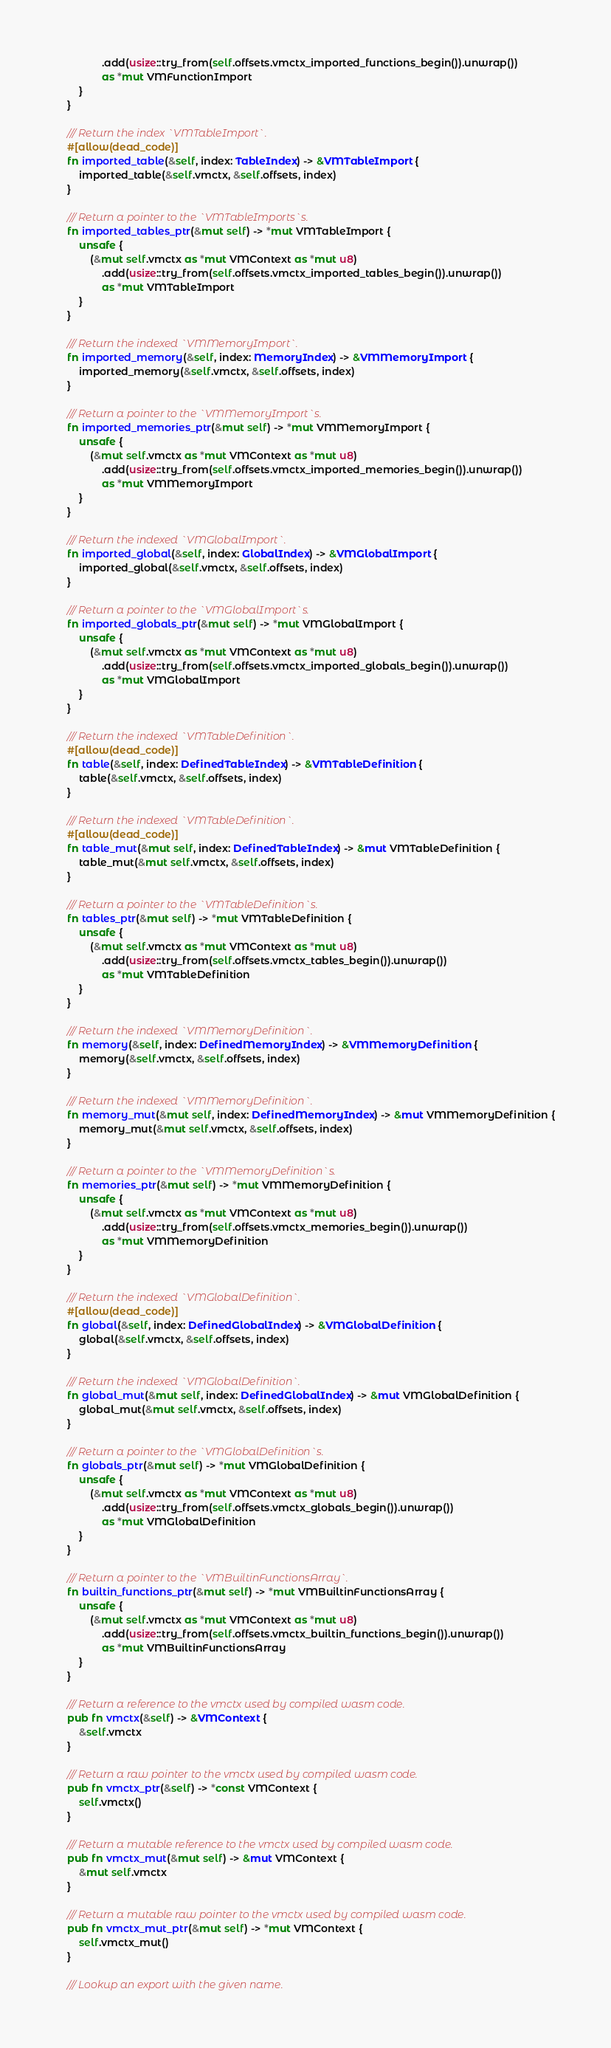<code> <loc_0><loc_0><loc_500><loc_500><_Rust_>                .add(usize::try_from(self.offsets.vmctx_imported_functions_begin()).unwrap())
                as *mut VMFunctionImport
        }
    }

    /// Return the index `VMTableImport`.
    #[allow(dead_code)]
    fn imported_table(&self, index: TableIndex) -> &VMTableImport {
        imported_table(&self.vmctx, &self.offsets, index)
    }

    /// Return a pointer to the `VMTableImports`s.
    fn imported_tables_ptr(&mut self) -> *mut VMTableImport {
        unsafe {
            (&mut self.vmctx as *mut VMContext as *mut u8)
                .add(usize::try_from(self.offsets.vmctx_imported_tables_begin()).unwrap())
                as *mut VMTableImport
        }
    }

    /// Return the indexed `VMMemoryImport`.
    fn imported_memory(&self, index: MemoryIndex) -> &VMMemoryImport {
        imported_memory(&self.vmctx, &self.offsets, index)
    }

    /// Return a pointer to the `VMMemoryImport`s.
    fn imported_memories_ptr(&mut self) -> *mut VMMemoryImport {
        unsafe {
            (&mut self.vmctx as *mut VMContext as *mut u8)
                .add(usize::try_from(self.offsets.vmctx_imported_memories_begin()).unwrap())
                as *mut VMMemoryImport
        }
    }

    /// Return the indexed `VMGlobalImport`.
    fn imported_global(&self, index: GlobalIndex) -> &VMGlobalImport {
        imported_global(&self.vmctx, &self.offsets, index)
    }

    /// Return a pointer to the `VMGlobalImport`s.
    fn imported_globals_ptr(&mut self) -> *mut VMGlobalImport {
        unsafe {
            (&mut self.vmctx as *mut VMContext as *mut u8)
                .add(usize::try_from(self.offsets.vmctx_imported_globals_begin()).unwrap())
                as *mut VMGlobalImport
        }
    }

    /// Return the indexed `VMTableDefinition`.
    #[allow(dead_code)]
    fn table(&self, index: DefinedTableIndex) -> &VMTableDefinition {
        table(&self.vmctx, &self.offsets, index)
    }

    /// Return the indexed `VMTableDefinition`.
    #[allow(dead_code)]
    fn table_mut(&mut self, index: DefinedTableIndex) -> &mut VMTableDefinition {
        table_mut(&mut self.vmctx, &self.offsets, index)
    }

    /// Return a pointer to the `VMTableDefinition`s.
    fn tables_ptr(&mut self) -> *mut VMTableDefinition {
        unsafe {
            (&mut self.vmctx as *mut VMContext as *mut u8)
                .add(usize::try_from(self.offsets.vmctx_tables_begin()).unwrap())
                as *mut VMTableDefinition
        }
    }

    /// Return the indexed `VMMemoryDefinition`.
    fn memory(&self, index: DefinedMemoryIndex) -> &VMMemoryDefinition {
        memory(&self.vmctx, &self.offsets, index)
    }

    /// Return the indexed `VMMemoryDefinition`.
    fn memory_mut(&mut self, index: DefinedMemoryIndex) -> &mut VMMemoryDefinition {
        memory_mut(&mut self.vmctx, &self.offsets, index)
    }

    /// Return a pointer to the `VMMemoryDefinition`s.
    fn memories_ptr(&mut self) -> *mut VMMemoryDefinition {
        unsafe {
            (&mut self.vmctx as *mut VMContext as *mut u8)
                .add(usize::try_from(self.offsets.vmctx_memories_begin()).unwrap())
                as *mut VMMemoryDefinition
        }
    }

    /// Return the indexed `VMGlobalDefinition`.
    #[allow(dead_code)]
    fn global(&self, index: DefinedGlobalIndex) -> &VMGlobalDefinition {
        global(&self.vmctx, &self.offsets, index)
    }

    /// Return the indexed `VMGlobalDefinition`.
    fn global_mut(&mut self, index: DefinedGlobalIndex) -> &mut VMGlobalDefinition {
        global_mut(&mut self.vmctx, &self.offsets, index)
    }

    /// Return a pointer to the `VMGlobalDefinition`s.
    fn globals_ptr(&mut self) -> *mut VMGlobalDefinition {
        unsafe {
            (&mut self.vmctx as *mut VMContext as *mut u8)
                .add(usize::try_from(self.offsets.vmctx_globals_begin()).unwrap())
                as *mut VMGlobalDefinition
        }
    }

    /// Return a pointer to the `VMBuiltinFunctionsArray`.
    fn builtin_functions_ptr(&mut self) -> *mut VMBuiltinFunctionsArray {
        unsafe {
            (&mut self.vmctx as *mut VMContext as *mut u8)
                .add(usize::try_from(self.offsets.vmctx_builtin_functions_begin()).unwrap())
                as *mut VMBuiltinFunctionsArray
        }
    }

    /// Return a reference to the vmctx used by compiled wasm code.
    pub fn vmctx(&self) -> &VMContext {
        &self.vmctx
    }

    /// Return a raw pointer to the vmctx used by compiled wasm code.
    pub fn vmctx_ptr(&self) -> *const VMContext {
        self.vmctx()
    }

    /// Return a mutable reference to the vmctx used by compiled wasm code.
    pub fn vmctx_mut(&mut self) -> &mut VMContext {
        &mut self.vmctx
    }

    /// Return a mutable raw pointer to the vmctx used by compiled wasm code.
    pub fn vmctx_mut_ptr(&mut self) -> *mut VMContext {
        self.vmctx_mut()
    }

    /// Lookup an export with the given name.</code> 